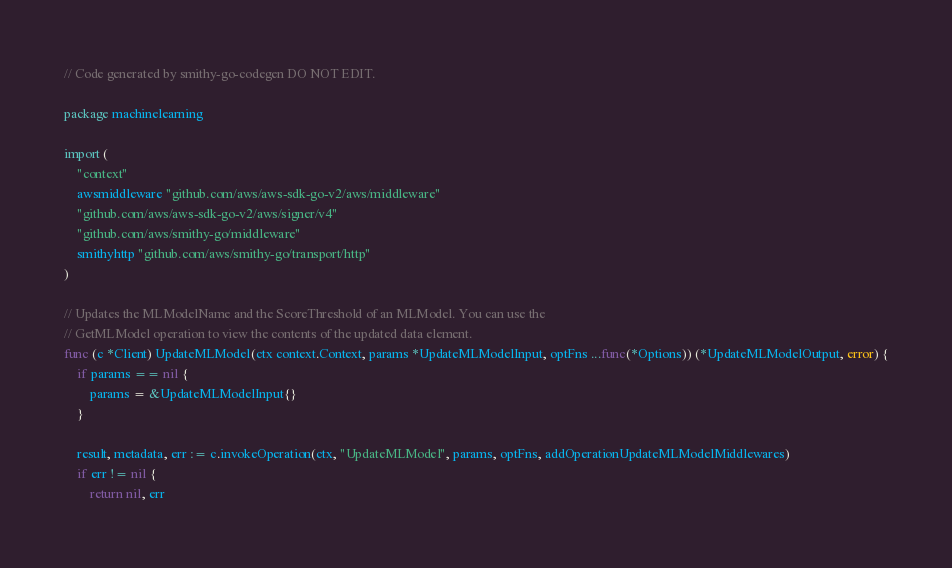Convert code to text. <code><loc_0><loc_0><loc_500><loc_500><_Go_>// Code generated by smithy-go-codegen DO NOT EDIT.

package machinelearning

import (
	"context"
	awsmiddleware "github.com/aws/aws-sdk-go-v2/aws/middleware"
	"github.com/aws/aws-sdk-go-v2/aws/signer/v4"
	"github.com/aws/smithy-go/middleware"
	smithyhttp "github.com/aws/smithy-go/transport/http"
)

// Updates the MLModelName and the ScoreThreshold of an MLModel. You can use the
// GetMLModel operation to view the contents of the updated data element.
func (c *Client) UpdateMLModel(ctx context.Context, params *UpdateMLModelInput, optFns ...func(*Options)) (*UpdateMLModelOutput, error) {
	if params == nil {
		params = &UpdateMLModelInput{}
	}

	result, metadata, err := c.invokeOperation(ctx, "UpdateMLModel", params, optFns, addOperationUpdateMLModelMiddlewares)
	if err != nil {
		return nil, err</code> 